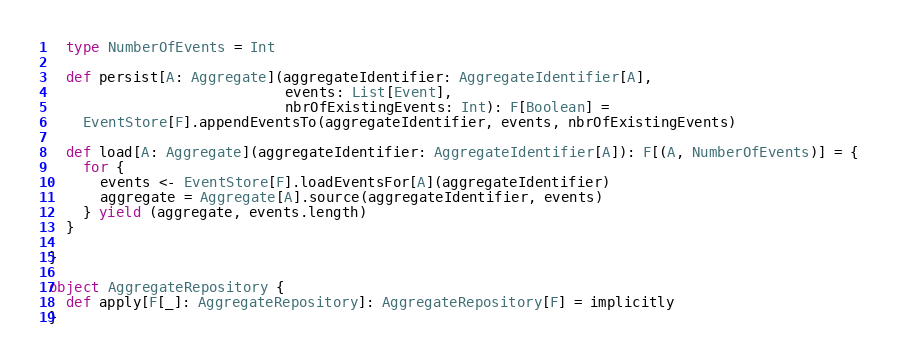<code> <loc_0><loc_0><loc_500><loc_500><_Scala_>
  type NumberOfEvents = Int

  def persist[A: Aggregate](aggregateIdentifier: AggregateIdentifier[A],
                            events: List[Event],
                            nbrOfExistingEvents: Int): F[Boolean] =
    EventStore[F].appendEventsTo(aggregateIdentifier, events, nbrOfExistingEvents)

  def load[A: Aggregate](aggregateIdentifier: AggregateIdentifier[A]): F[(A, NumberOfEvents)] = {
    for {
      events <- EventStore[F].loadEventsFor[A](aggregateIdentifier)
      aggregate = Aggregate[A].source(aggregateIdentifier, events)
    } yield (aggregate, events.length)
  }

}

object AggregateRepository {
  def apply[F[_]: AggregateRepository]: AggregateRepository[F] = implicitly
}
</code> 